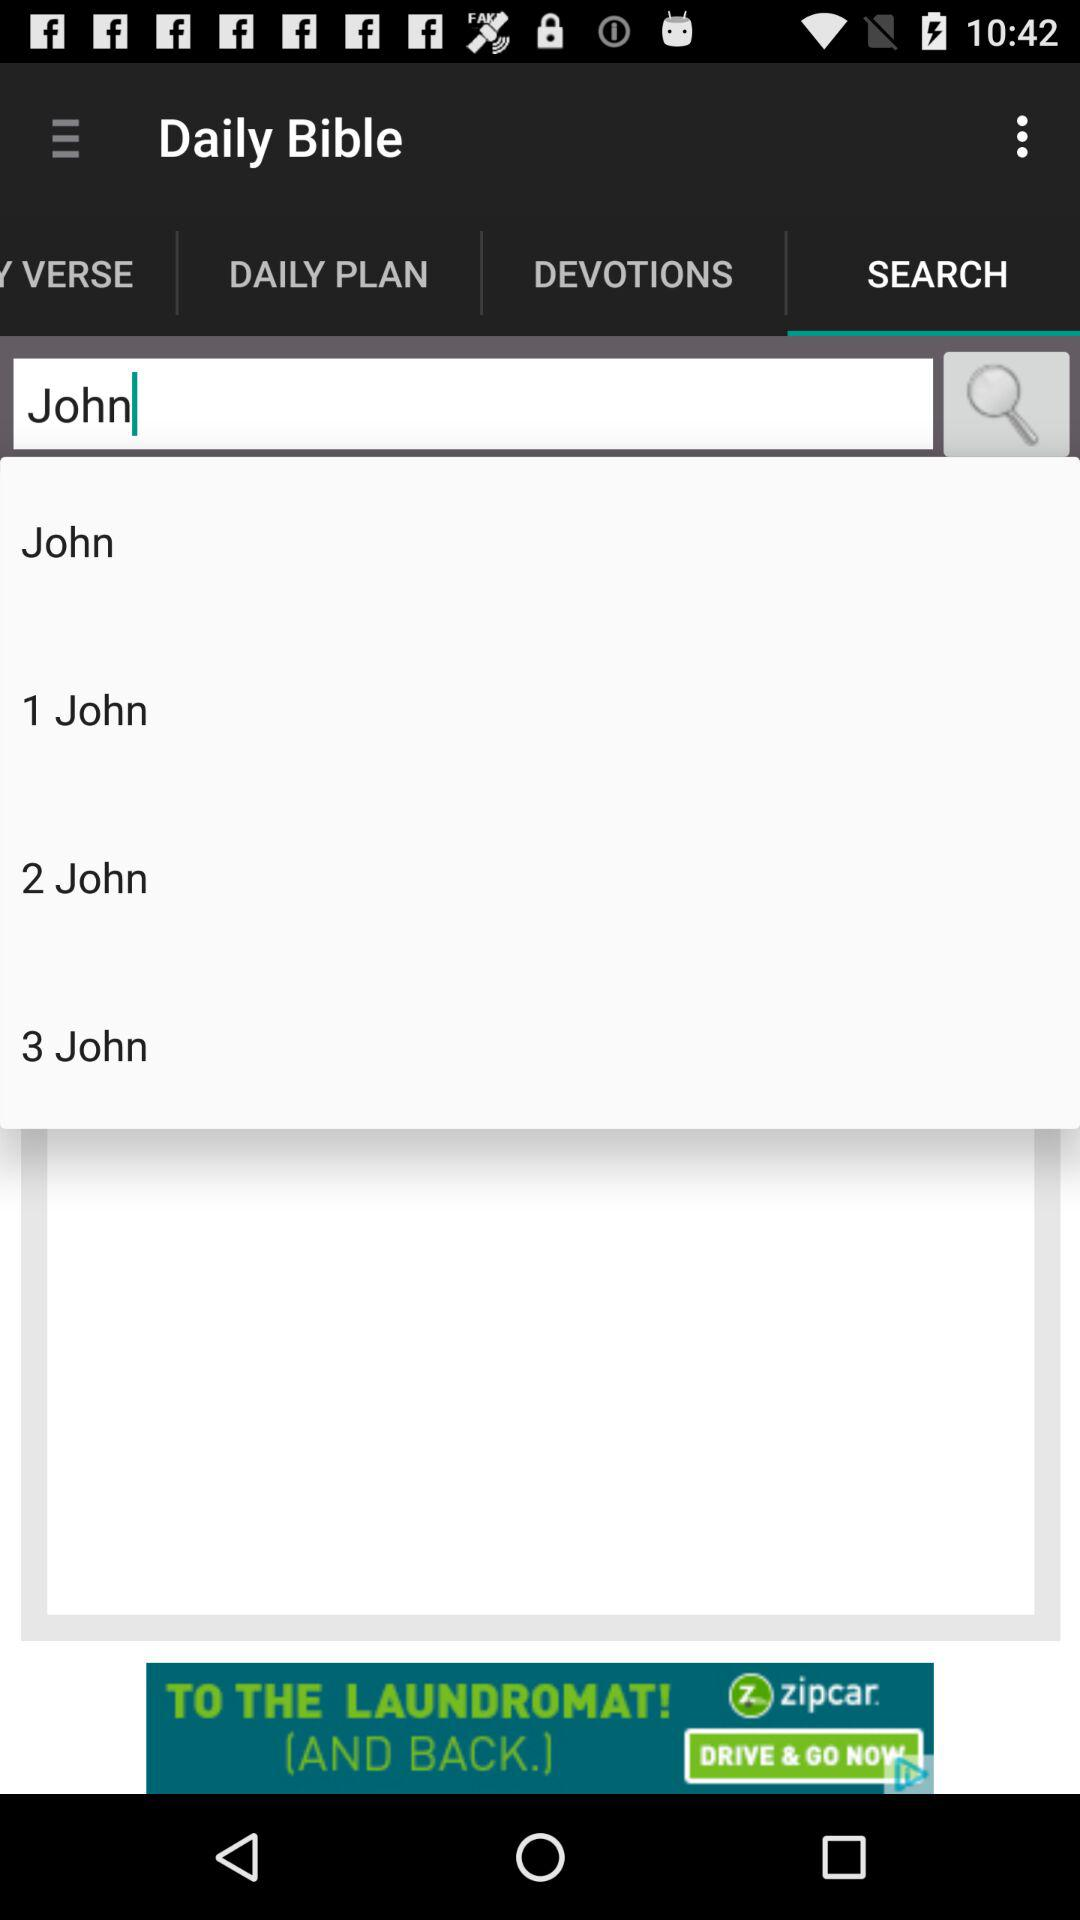For what word is the person searching? The word is "John". 